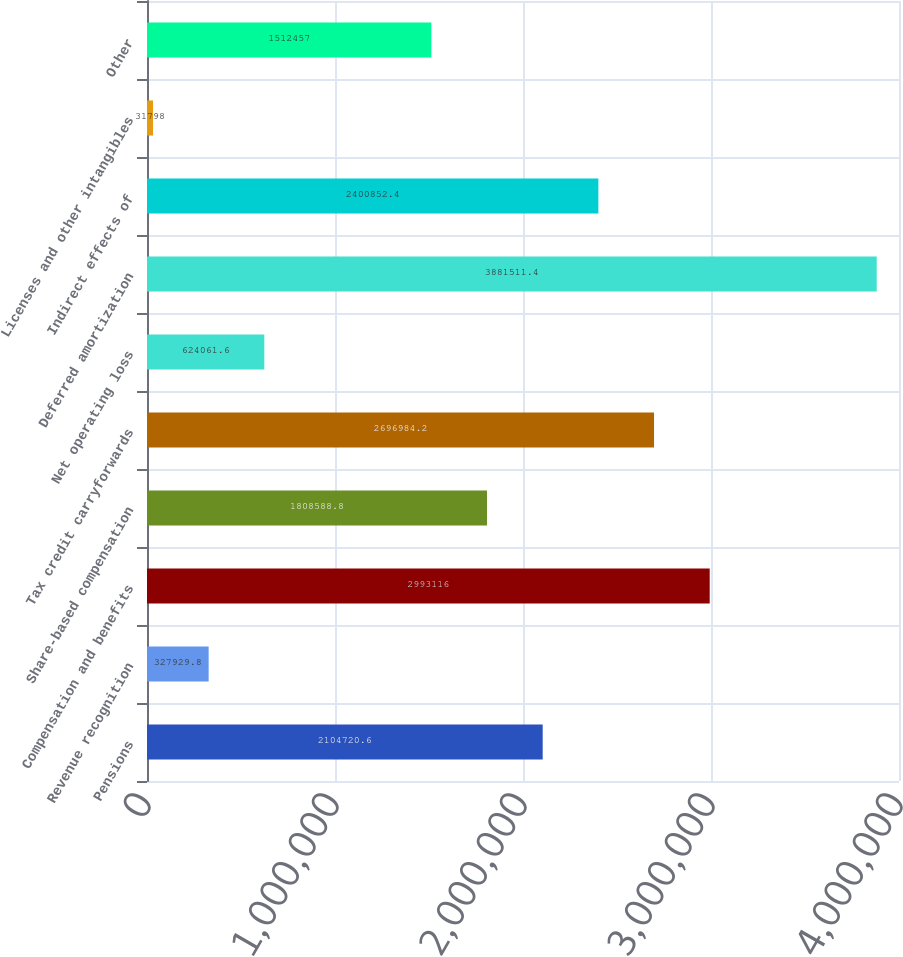<chart> <loc_0><loc_0><loc_500><loc_500><bar_chart><fcel>Pensions<fcel>Revenue recognition<fcel>Compensation and benefits<fcel>Share-based compensation<fcel>Tax credit carryforwards<fcel>Net operating loss<fcel>Deferred amortization<fcel>Indirect effects of<fcel>Licenses and other intangibles<fcel>Other<nl><fcel>2.10472e+06<fcel>327930<fcel>2.99312e+06<fcel>1.80859e+06<fcel>2.69698e+06<fcel>624062<fcel>3.88151e+06<fcel>2.40085e+06<fcel>31798<fcel>1.51246e+06<nl></chart> 